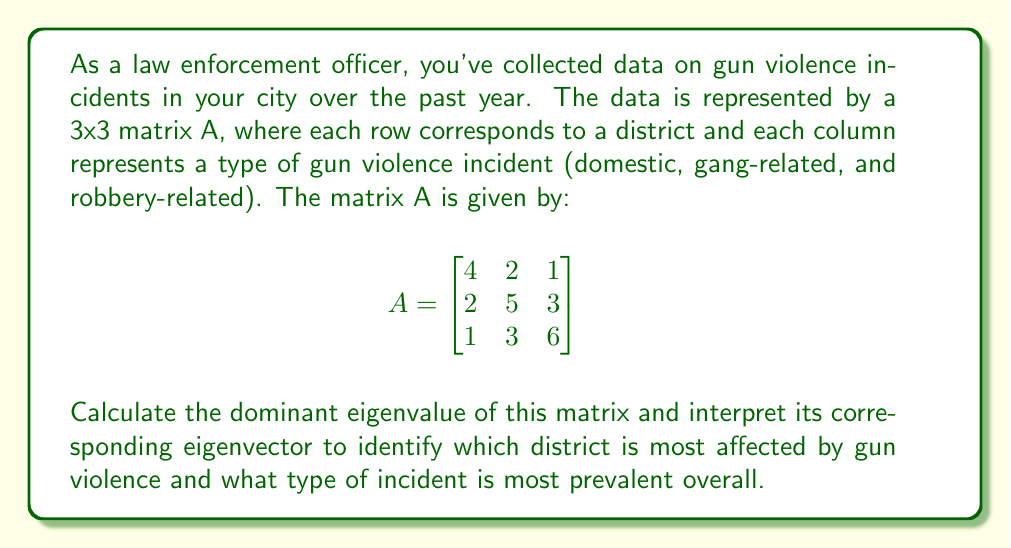Give your solution to this math problem. To solve this problem, we'll follow these steps:

1) First, we need to find the eigenvalues of matrix A. The characteristic equation is:

   $$det(A - \lambda I) = 0$$

2) Expanding this:

   $$\begin{vmatrix}
   4-\lambda & 2 & 1 \\
   2 & 5-\lambda & 3 \\
   1 & 3 & 6-\lambda
   \end{vmatrix} = 0$$

3) This gives us the cubic equation:

   $$-\lambda^3 + 15\lambda^2 - 59\lambda + 60 = 0$$

4) Solving this equation (using a calculator or computer algebra system) gives us the eigenvalues:

   $$\lambda_1 \approx 9.4721, \lambda_2 \approx 3.7639, \lambda_3 \approx 1.7640$$

5) The dominant eigenvalue is the largest: $\lambda_1 \approx 9.4721$

6) Now we need to find the eigenvector corresponding to this eigenvalue. We solve:

   $$(A - \lambda_1 I)v = 0$$

7) This gives us the system of equations:

   $$\begin{cases}
   -5.4721v_1 + 2v_2 + v_3 = 0 \\
   2v_1 - 4.4721v_2 + 3v_3 = 0 \\
   v_1 + 3v_2 - 3.4721v_3 = 0
   \end{cases}$$

8) Solving this system (again, using computational tools) gives us the eigenvector:

   $$v \approx (0.4450, 0.5976, 0.6664)$$

9) Interpreting this eigenvector:
   - The largest component is the third (0.6664), corresponding to the third district.
   - The second largest is the second component (0.5976), corresponding to gang-related incidents.
Answer: Dominant eigenvalue: 9.4721. Most affected district: 3rd. Most prevalent incident type: gang-related. 